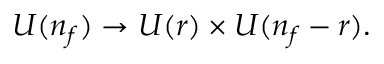Convert formula to latex. <formula><loc_0><loc_0><loc_500><loc_500>U ( n _ { f } ) \rightarrow U ( r ) \times U ( n _ { f } - r ) .</formula> 